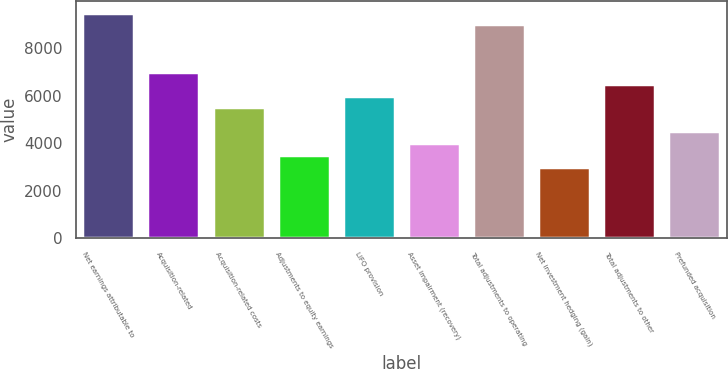Convert chart. <chart><loc_0><loc_0><loc_500><loc_500><bar_chart><fcel>Net earnings attributable to<fcel>Acquisition-related<fcel>Acquisition-related costs<fcel>Adjustments to equity earnings<fcel>LIFO provision<fcel>Asset impairment (recovery)<fcel>Total adjustments to operating<fcel>Net investment hedging (gain)<fcel>Total adjustments to other<fcel>Prefunded acquisition<nl><fcel>9517.14<fcel>7012.64<fcel>5509.94<fcel>3506.34<fcel>6010.84<fcel>4007.24<fcel>9016.24<fcel>3005.44<fcel>6511.74<fcel>4508.14<nl></chart> 